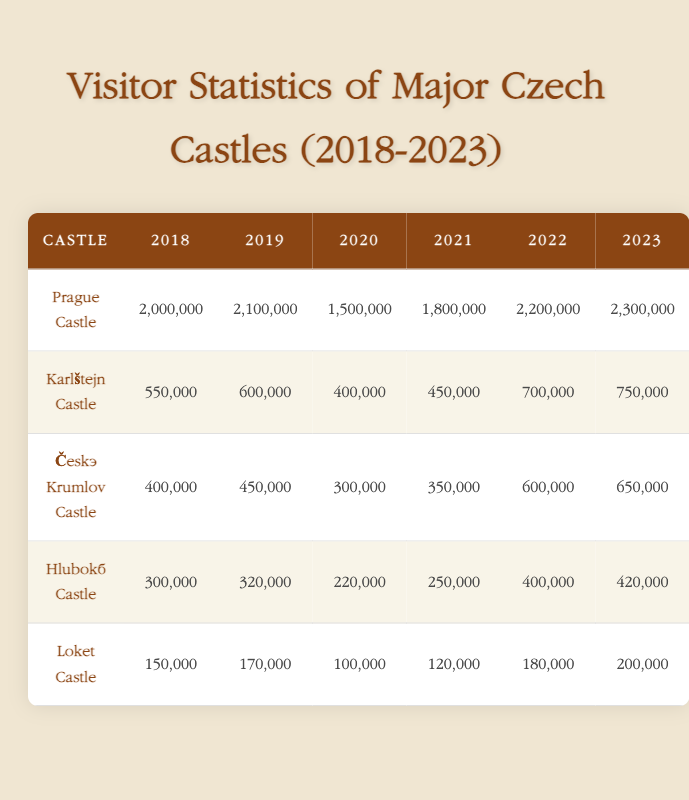What was the highest number of visitors to Prague Castle during the years 2018 to 2023? The highest number of visitors to Prague Castle was in 2023, with a total of 2,300,000 visitors. This can be confirmed by checking the visitors' column for Prague Castle, where the numbers are listed annually.
Answer: 2,300,000 How many total visitors did Karlštejn Castle receive from 2018 to 2023? To find the total visitors for Karlštejn Castle, we sum the visitors from all six years: 550,000 + 600,000 + 400,000 + 450,000 + 700,000 + 750,000 = 3,450,000.
Answer: 3,450,000 In which year did Hluboká Castle have the fewest visitors, and how many were there? Hluboká Castle had the fewest visitors in 2020, with a total of 220,000 visitors. This can be seen by comparing the numbers in the Hluboká Castle row of the table.
Answer: 2020, 220,000 Did Český Krumlov Castle's visitor numbers increase every year from 2018 to 2023? No, Český Krumlov Castle did not see an increase every year; the number of visitors decreased from 450,000 in 2019 to 300,000 in 2020. Thus, it had fluctuations in visitor numbers.
Answer: No What is the average number of visitors to Loket Castle over the years shown? To calculate the average, we sum the visitors over the years (150,000 + 170,000 + 100,000 + 120,000 + 180,000 + 200,000 = 1,020,000) and divide by the number of years (6). Thus, the average is 1,020,000 / 6 = 170,000.
Answer: 170,000 Which castle had the largest increase in visitors from 2021 to 2022? To determine this, we calculate the difference in visitors for each castle between 2021 and 2022. Prague Castle had an increase of 400,000 (2,200,000 - 1,800,000), and Karlštejn had an increase of 250,000 (700,000 - 450,000). Therefore, the largest increase was for Prague Castle.
Answer: Prague Castle How many visitors did Hluboká Castle have in 2023? The number of visitors to Hluboká Castle in 2023 is directly listed in the table as 420,000. This can be found in the respective row and column for that year.
Answer: 420,000 Was the total number of visitors to Czech castles greater in 2023 than in 2022? Yes, the total visitors in 2023, calculated by summing the visitors of all castles, amounted to 4,475,000, compared to 4,190,000 in 2022.
Answer: Yes 